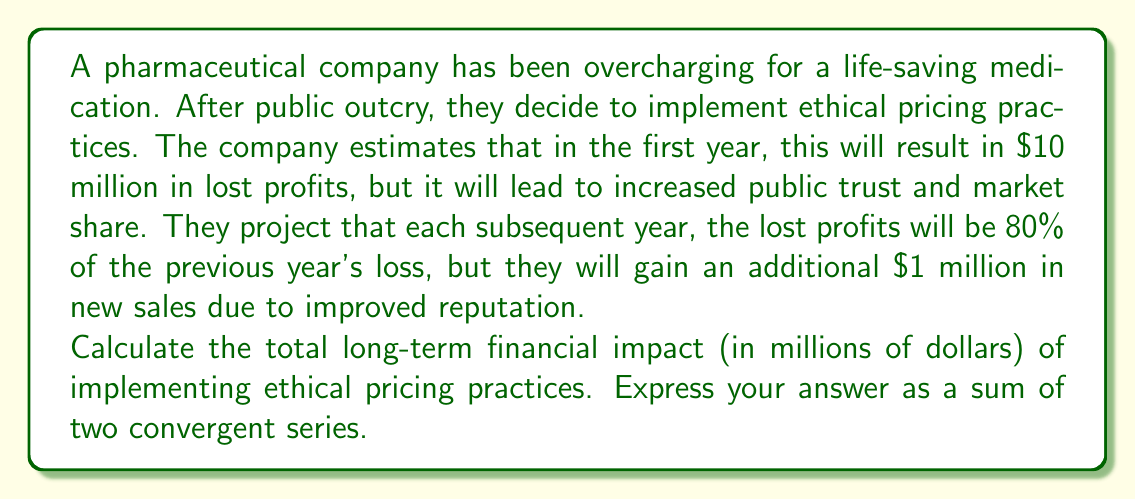Can you solve this math problem? Let's break this problem down into two series:

1. Series A: The decreasing lost profits
2. Series B: The increasing gains from improved reputation

For Series A:
The initial term $a_1 = 10$ (million dollars), and each subsequent term is 80% of the previous.
This forms a geometric series with first term $a = 10$ and common ratio $r = 0.8$

The sum of this infinite geometric series is given by the formula:
$$S_A = \frac{a}{1-r} = \frac{10}{1-0.8} = \frac{10}{0.2} = 50$$

For Series B:
This is an arithmetic sequence with a constant difference of 1 million dollars per year.
The sum of this infinite arithmetic series is divergent, but we can express it as:
$$S_B = 1 + 2 + 3 + 4 + ...$$

The total long-term financial impact is the difference between Series B and Series A:

$$(1 + 2 + 3 + 4 + ...) - 50$$

This can be written as the sum of two convergent series:
$$(1 + 2 + 3 + 4 + ...) - (50 + 0 + 0 + 0 + ...)$$

The first series represents the increasing gains, while the second represents the total losses.
Answer: $(1 + 2 + 3 + 4 + ...) - (50 + 0 + 0 + 0 + ...)$ million dollars 